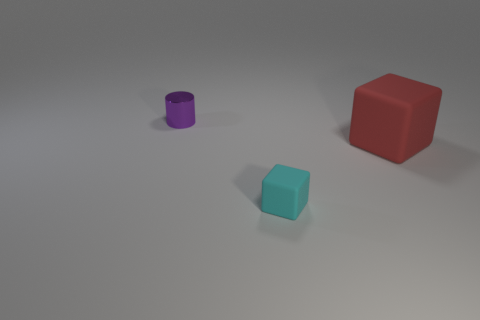What is the shape of the object that is behind the matte thing that is to the right of the small object to the right of the small purple thing?
Offer a terse response. Cylinder. What shape is the thing that is behind the cyan rubber thing and on the left side of the big red object?
Your answer should be very brief. Cylinder. Is the material of the cyan cube the same as the large thing?
Your answer should be very brief. Yes. What is the size of the object that is in front of the purple object and to the left of the big matte cube?
Your answer should be compact. Small. Does the rubber thing that is in front of the large red matte cube have the same shape as the small object left of the tiny cyan cube?
Your response must be concise. No. There is a small thing that is behind the object that is in front of the red block; what is it made of?
Offer a terse response. Metal. How many objects are red matte cubes or purple metal things?
Your response must be concise. 2. Are there fewer red rubber cubes than tiny cyan metal objects?
Your answer should be very brief. No. What is the size of the other object that is made of the same material as the red thing?
Offer a very short reply. Small. The cyan block is what size?
Ensure brevity in your answer.  Small. 